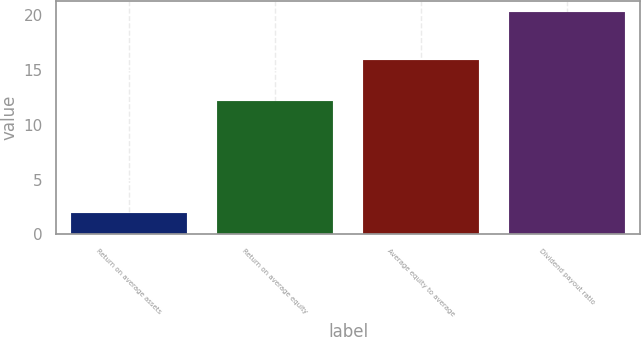Convert chart. <chart><loc_0><loc_0><loc_500><loc_500><bar_chart><fcel>Return on average assets<fcel>Return on average equity<fcel>Average equity to average<fcel>Dividend payout ratio<nl><fcel>1.9<fcel>12.2<fcel>15.9<fcel>20.3<nl></chart> 